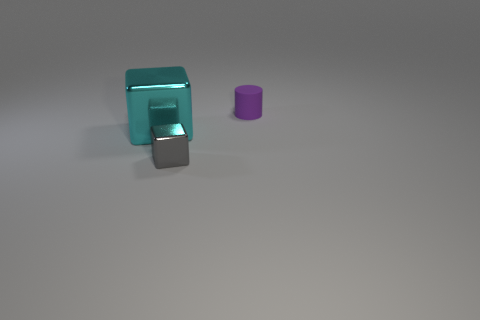Add 1 red matte cubes. How many objects exist? 4 Subtract all cylinders. How many objects are left? 2 Add 2 small purple things. How many small purple things are left? 3 Add 3 tiny yellow matte cubes. How many tiny yellow matte cubes exist? 3 Subtract 1 cyan blocks. How many objects are left? 2 Subtract all tiny shiny things. Subtract all cyan objects. How many objects are left? 1 